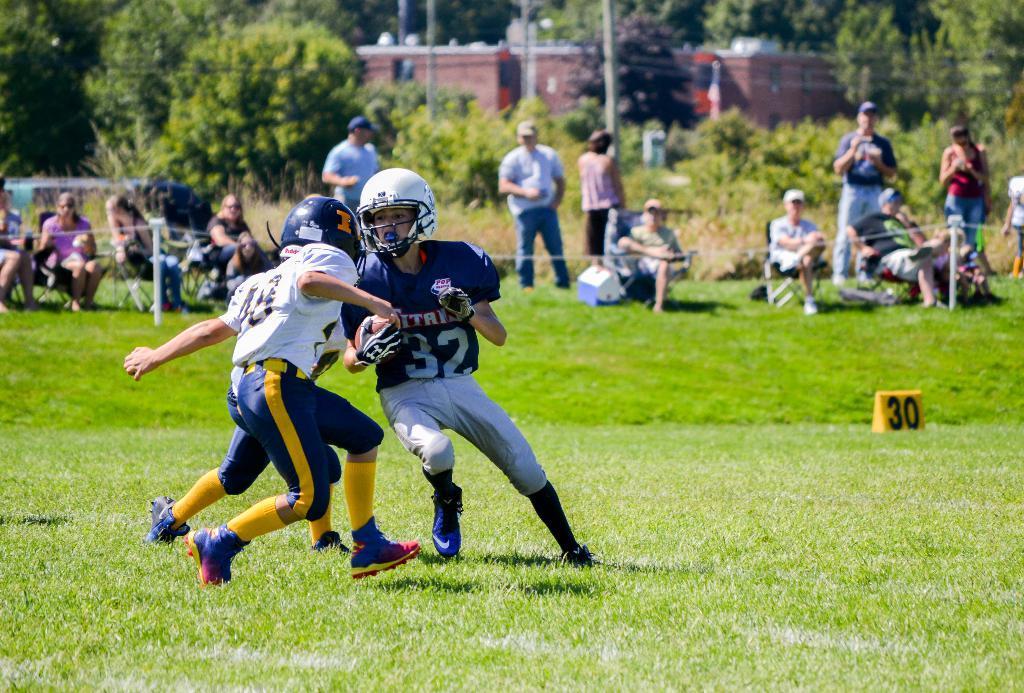How would you summarize this image in a sentence or two? In this image few persons are playing on the grass land. A person is holding a ball in his hand. Behind there is a fence. Behind it there are few persons sitting on the chairs. Few persons are standing on the grassland. There are few plants and trees. Behind there is a building. 